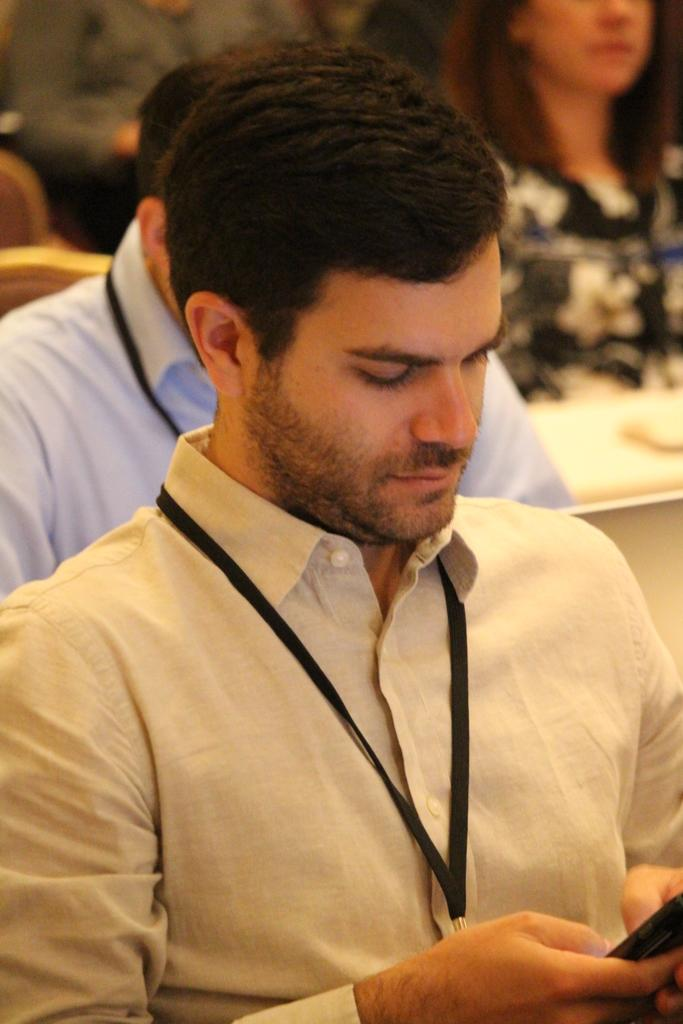What is the main subject of the image? There is a man in the image. What is the man doing in the image? The man is holding an object. Are there any other people visible in the image? Yes, there are people visible behind the man. Can you describe the background of the image? The background of the image is blurred. What type of ant can be seen crawling on the man's cap in the image? There is no ant or cap present in the image, so this question cannot be answered. 